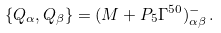Convert formula to latex. <formula><loc_0><loc_0><loc_500><loc_500>\{ Q _ { \alpha } , Q _ { \beta } \} = ( M + P _ { 5 } \Gamma ^ { 5 0 } ) ^ { - } _ { \alpha \beta } \, .</formula> 